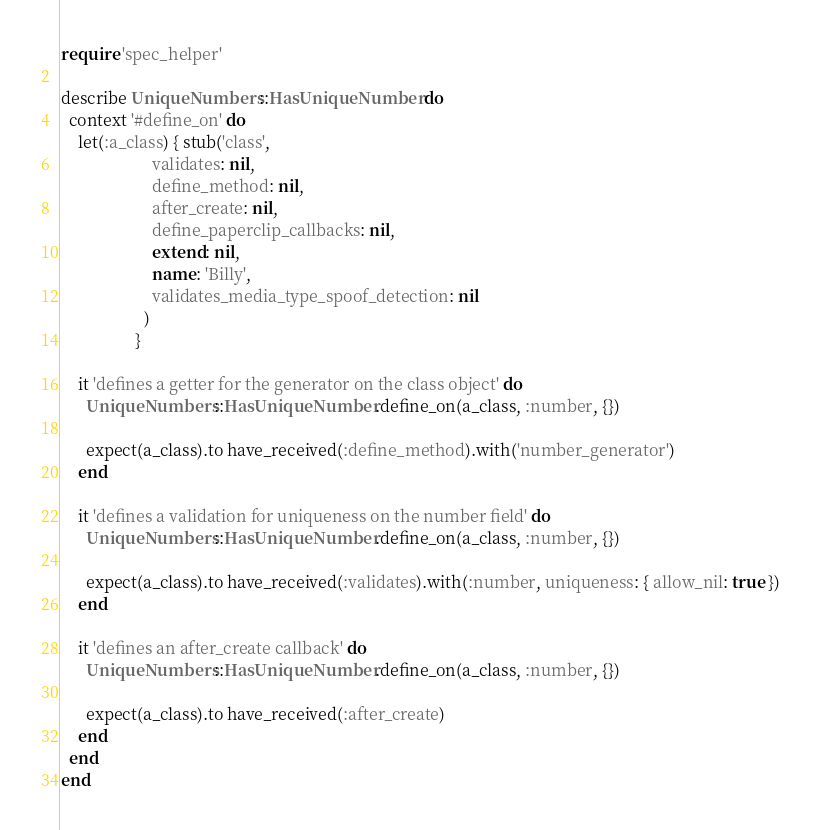Convert code to text. <code><loc_0><loc_0><loc_500><loc_500><_Ruby_>require 'spec_helper'

describe UniqueNumbers::HasUniqueNumber do
  context '#define_on' do
    let(:a_class) { stub('class',
                      validates: nil,
                      define_method: nil,
                      after_create: nil,
                      define_paperclip_callbacks: nil,
                      extend: nil,
                      name: 'Billy',
                      validates_media_type_spoof_detection: nil
                    )
                  }
    
    it 'defines a getter for the generator on the class object' do
      UniqueNumbers::HasUniqueNumber.define_on(a_class, :number, {})

      expect(a_class).to have_received(:define_method).with('number_generator')
    end

    it 'defines a validation for uniqueness on the number field' do
      UniqueNumbers::HasUniqueNumber.define_on(a_class, :number, {})

      expect(a_class).to have_received(:validates).with(:number, uniqueness: { allow_nil: true })
    end

    it 'defines an after_create callback' do
      UniqueNumbers::HasUniqueNumber.define_on(a_class, :number, {})

      expect(a_class).to have_received(:after_create)
    end
  end
end</code> 